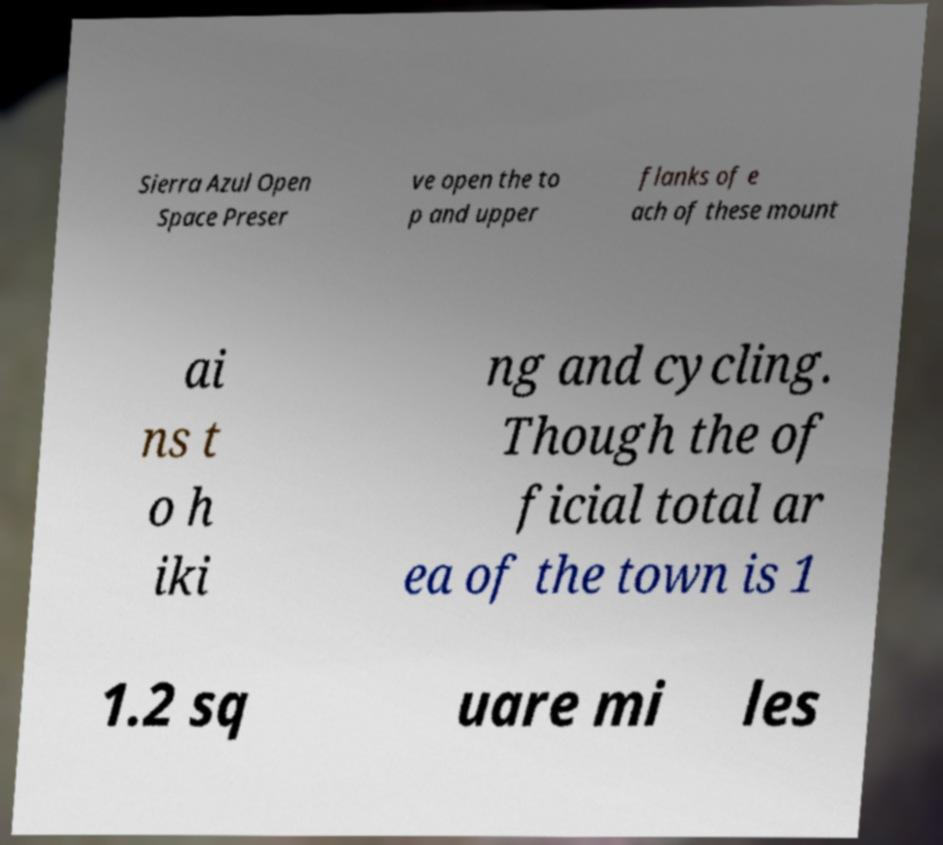Could you assist in decoding the text presented in this image and type it out clearly? Sierra Azul Open Space Preser ve open the to p and upper flanks of e ach of these mount ai ns t o h iki ng and cycling. Though the of ficial total ar ea of the town is 1 1.2 sq uare mi les 